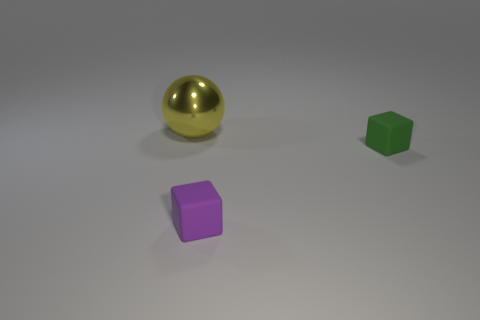Subtract all gray spheres. Subtract all green cubes. How many spheres are left? 1 Add 1 tiny purple rubber blocks. How many objects exist? 4 Subtract all balls. How many objects are left? 2 Add 3 small purple cubes. How many small purple cubes exist? 4 Subtract 0 blue balls. How many objects are left? 3 Subtract all big gray blocks. Subtract all small purple matte objects. How many objects are left? 2 Add 2 big things. How many big things are left? 3 